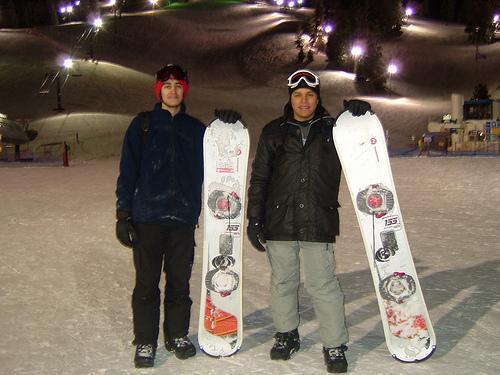Why are the lights on at this ski resort?
Choose the right answer from the provided options to respond to the question.
Options: It's raining, it's cloudy, it's storming, it's night. It's night. 